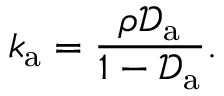Convert formula to latex. <formula><loc_0><loc_0><loc_500><loc_500>k _ { a } = \frac { \rho \mathcal { D } _ { a } } { 1 - \mathcal { D } _ { a } } .</formula> 